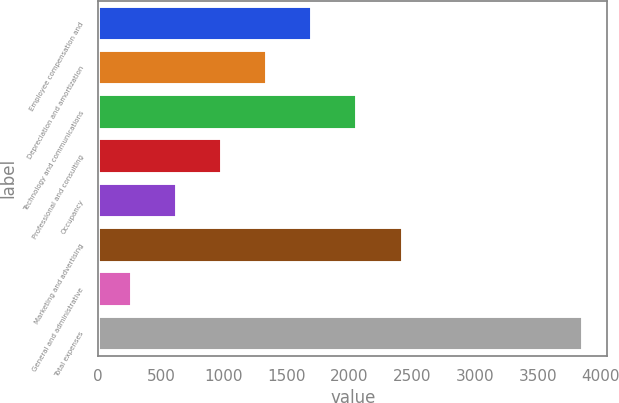<chart> <loc_0><loc_0><loc_500><loc_500><bar_chart><fcel>Employee compensation and<fcel>Depreciation and amortization<fcel>Technology and communications<fcel>Professional and consulting<fcel>Occupancy<fcel>Marketing and advertising<fcel>General and administrative<fcel>Total expenses<nl><fcel>1704.4<fcel>1345.3<fcel>2063.5<fcel>986.2<fcel>627.1<fcel>2422.6<fcel>268<fcel>3859<nl></chart> 